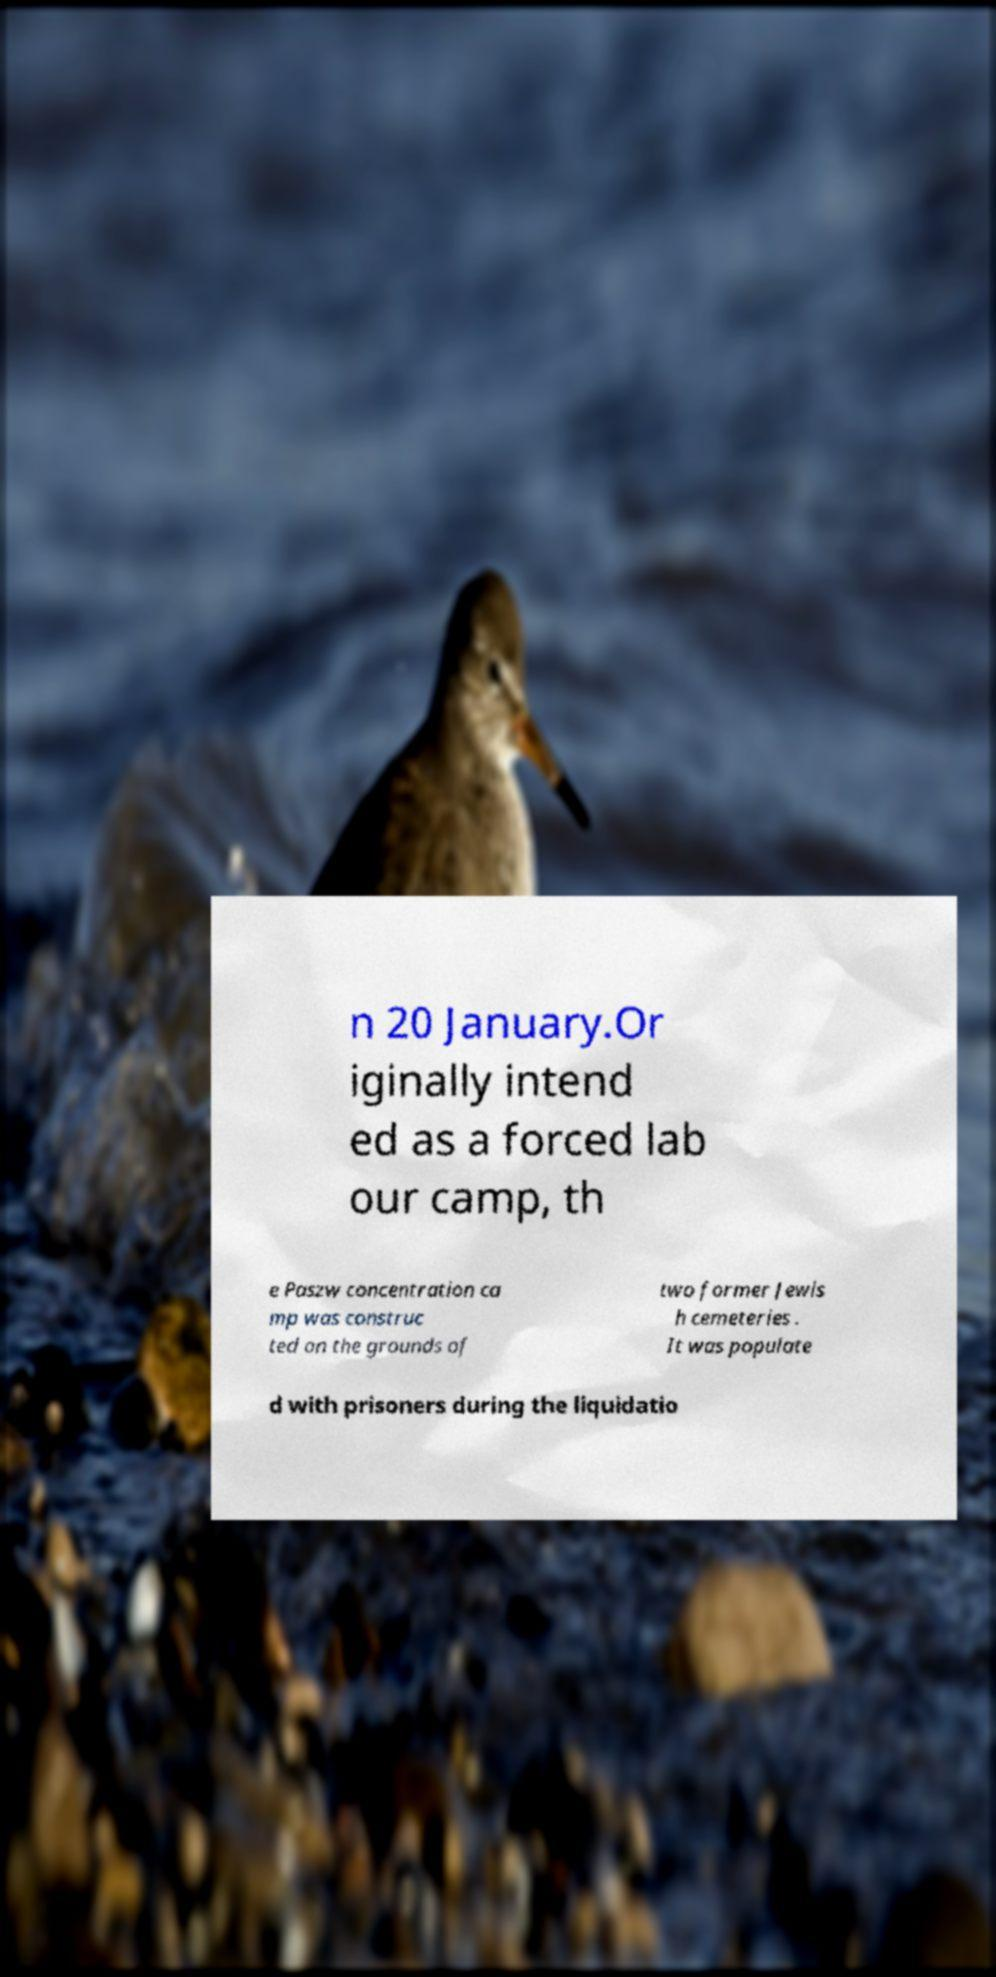Please identify and transcribe the text found in this image. n 20 January.Or iginally intend ed as a forced lab our camp, th e Paszw concentration ca mp was construc ted on the grounds of two former Jewis h cemeteries . It was populate d with prisoners during the liquidatio 